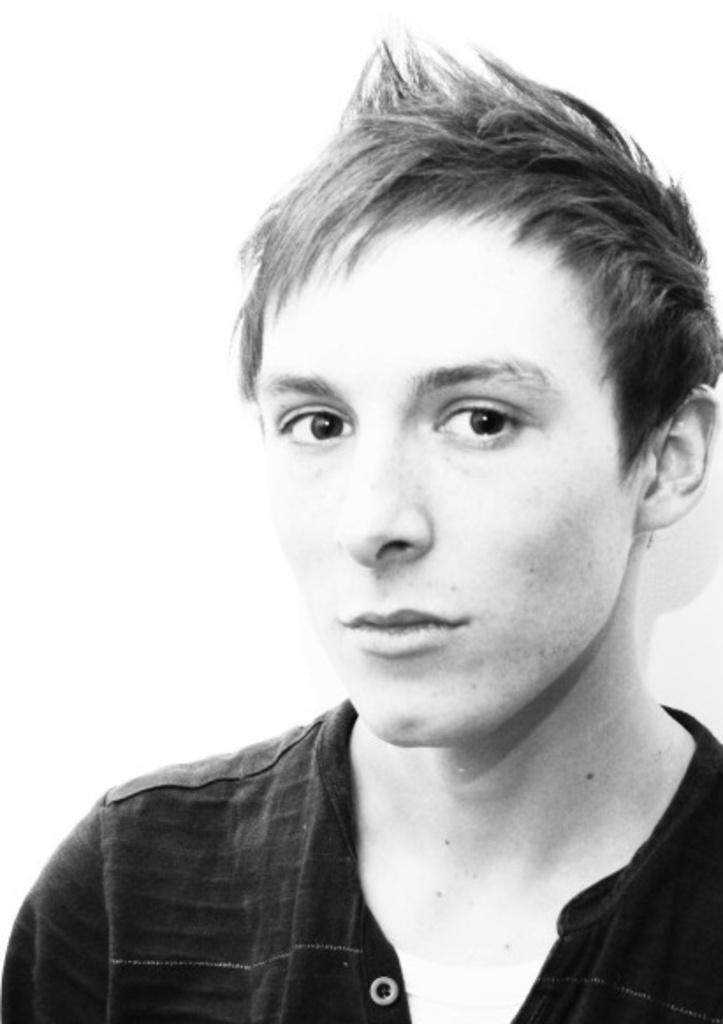Who is present in the image? There is a person in the image. What is the person wearing? The person is wearing a shirt. What is the person doing in the image? The person is watching something. What color is the background of the image? The background of the image is white. How does the person contribute to reducing pollution in the image? There is no information about pollution or any actions related to it in the image. 